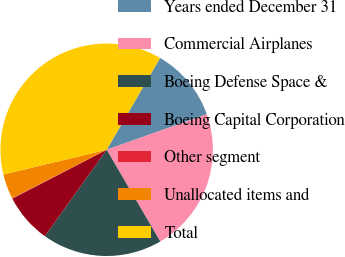<chart> <loc_0><loc_0><loc_500><loc_500><pie_chart><fcel>Years ended December 31<fcel>Commercial Airplanes<fcel>Boeing Defense Space &<fcel>Boeing Capital Corporation<fcel>Other segment<fcel>Unallocated items and<fcel>Total<nl><fcel>11.2%<fcel>22.0%<fcel>18.3%<fcel>7.5%<fcel>0.09%<fcel>3.79%<fcel>37.12%<nl></chart> 